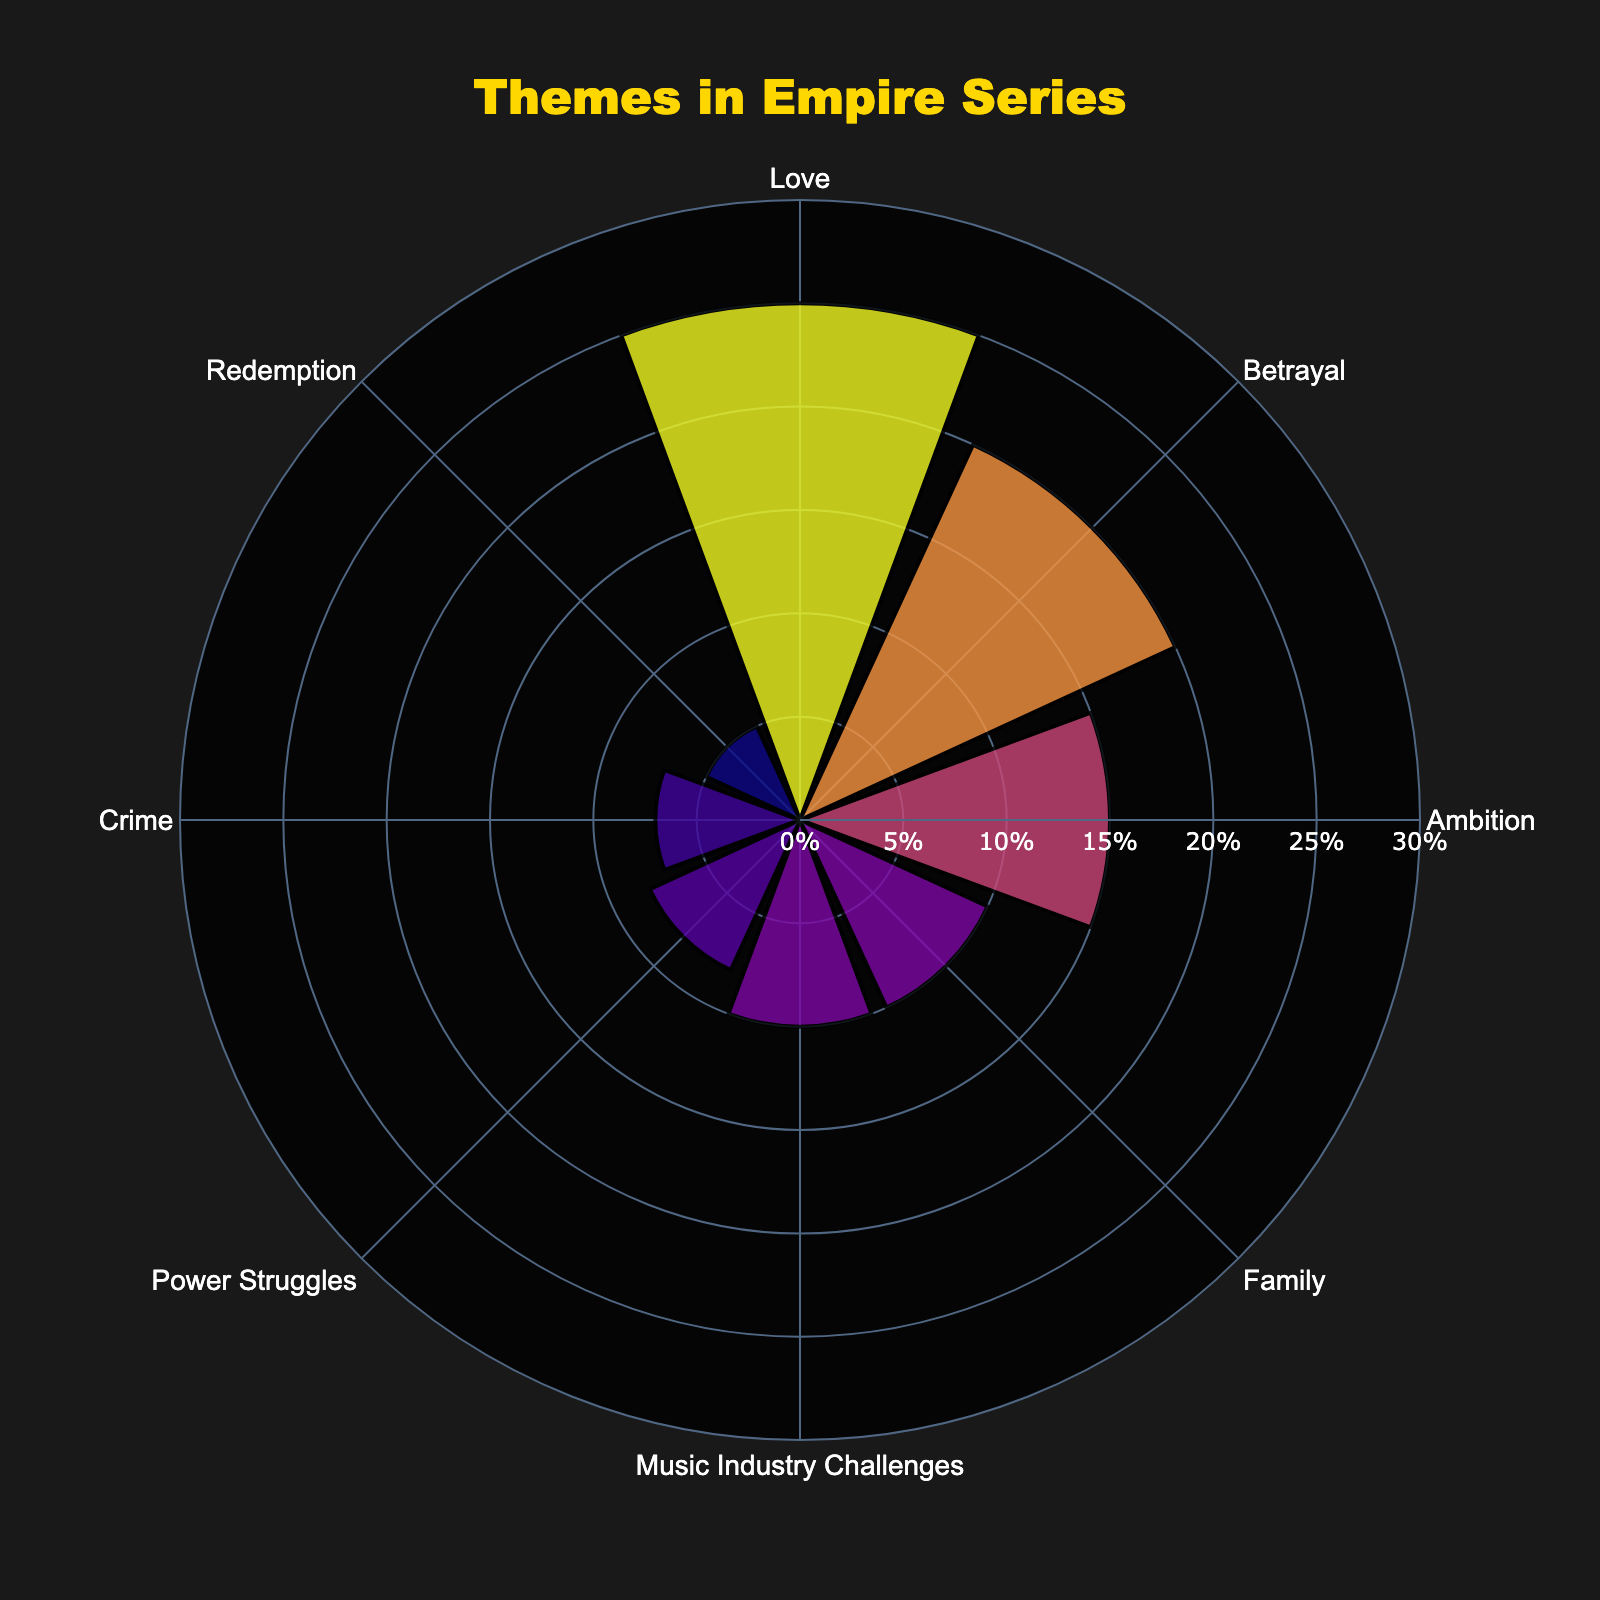what is the theme with the highest percentage in the Empire series? The title of the figure indicates it is about themes in the Empire series. The largest bar in the rose chart represents the theme with the highest percentage. The longest radius in the plot represents 'Love' with 25%.
Answer: Love Which theme has the second-highest percentage and what is it? Observing the second longest bar in the rose chart, we see that 'Betrayal' appears second with 20%.
Answer: Betrayal, 20% What are the total percentages for Family and Crime themes combined? By looking at the percentages of 'Family' (10%) and 'Crime' (7%) themes, we sum them up: 10 + 7 = 17%.
Answer: 17% Are there more plotlines featuring 'Power Struggles' or 'Redemption'? Comparing the bars, 'Power Struggles' has 8% and 'Redemption' has 5%. 8% is greater than 5%.
Answer: Power Struggles Which theme has a percentage closest to the average percentage of all themes? First, calculate the average percentage of all themes: \( \frac{25 + 20 + 15 + 10 + 10 + 8 + 7 + 5}{8} = 12.5\% \). Comparing individual percentages to 12.5%, ‘Ambition’ at 15% is the closest.
Answer: Ambition What's the difference in percentages between the 'Music Industry Challenges' and 'Crime' themes? From the rose chart, 'Music Industry Challenges' is 10% and 'Crime' is 7%. The difference is \(10 - 7 = 3\%\).
Answer: 3% Which theme appears in more plotlines: 'Family' or 'Redemption'? Observing the bars, 'Family' has 10% while 'Redemption' has 5%. 10% is greater than 5%.
Answer: Family How does the percentage of 'Ambition' themes compare to 'Power Struggles'? From the chart, 'Ambition' is 15% and 'Power Struggles' is 8%. 15% is greater than 8%.
Answer: Ambition What is the combined percentage for plotlines involving 'Love', 'Betrayal', and 'Ambition'? Summing the percentages of 'Love' (25%), 'Betrayal' (20%), and 'Ambition' (15%): \(25 + 20 + 15 = 60\%\).
Answer: 60% What is the least represented theme in the Empire series? The shortest bar in the rose chart represents the least common theme. In this case, 'Redemption' with 5%.
Answer: Redemption 